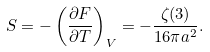<formula> <loc_0><loc_0><loc_500><loc_500>S = - \left ( \frac { \partial F } { \partial T } \right ) _ { V } = - \frac { \zeta ( 3 ) } { 1 6 \pi a ^ { 2 } } .</formula> 